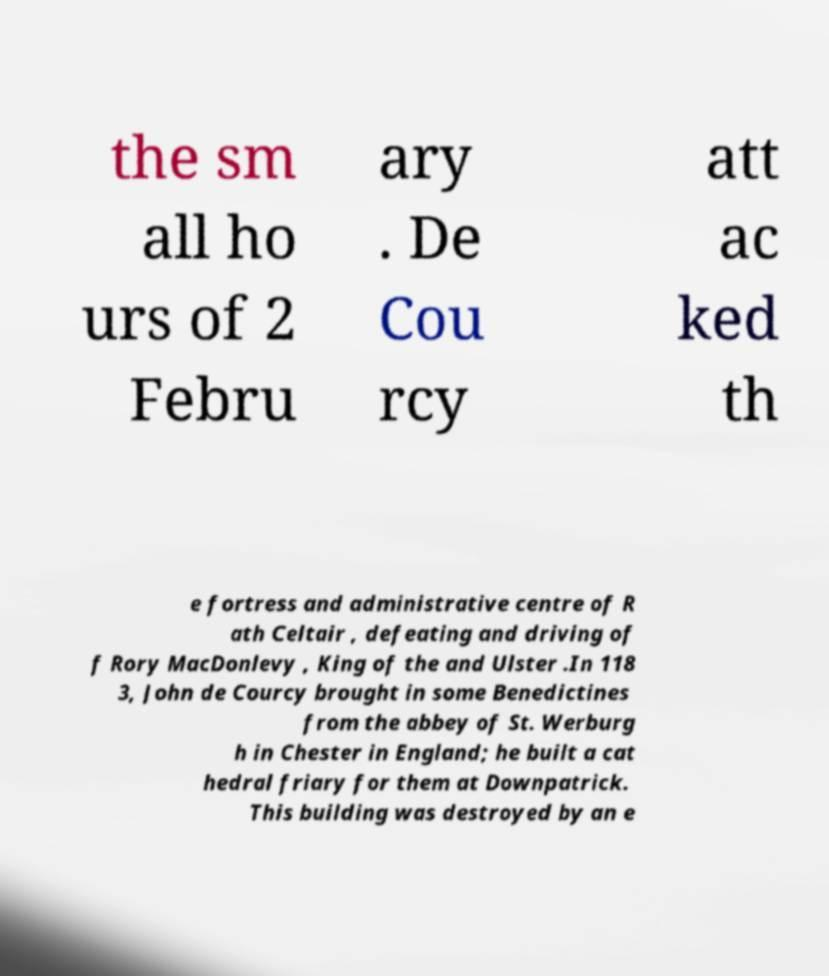Can you read and provide the text displayed in the image?This photo seems to have some interesting text. Can you extract and type it out for me? the sm all ho urs of 2 Febru ary . De Cou rcy att ac ked th e fortress and administrative centre of R ath Celtair , defeating and driving of f Rory MacDonlevy , King of the and Ulster .In 118 3, John de Courcy brought in some Benedictines from the abbey of St. Werburg h in Chester in England; he built a cat hedral friary for them at Downpatrick. This building was destroyed by an e 